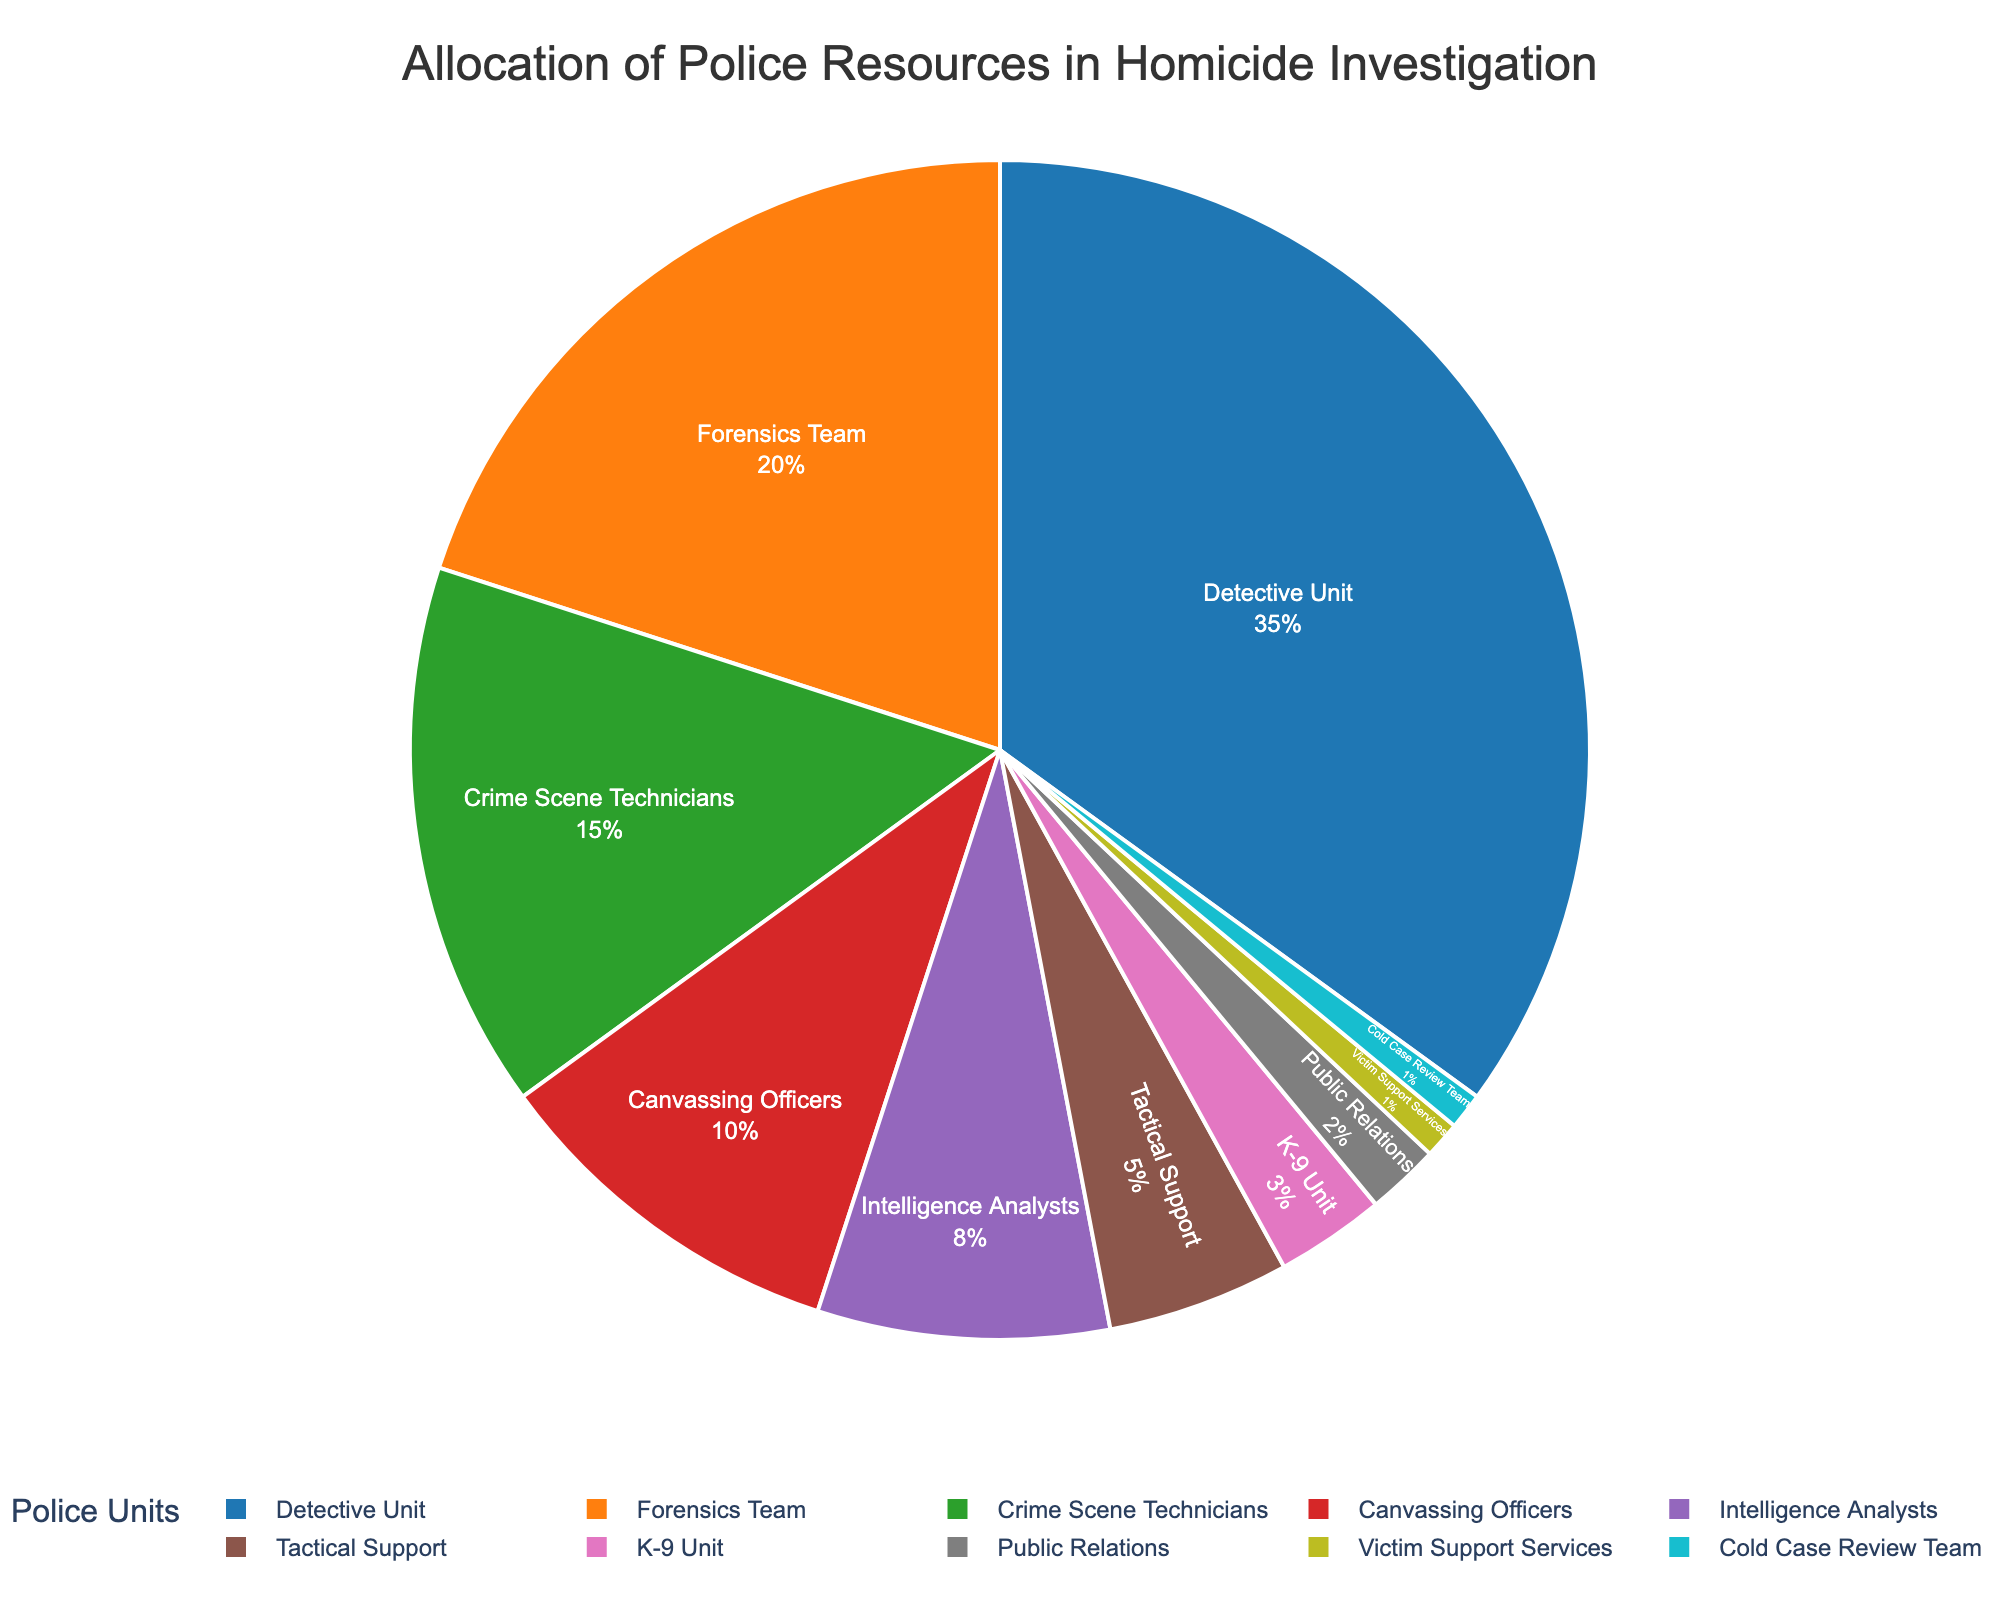Which unit has the highest allocation of police resources? The pie chart shows the percentage of resources allocated to each unit, and the largest segment represents the Detective Unit.
Answer: Detective Unit How much more percentage of resources does the Detective Unit receive compared to the Forensics Team? The Detective Unit receives 35%, and the Forensics Team receives 20%. The difference is 35% - 20%.
Answer: 15% What total percentage of resources is allocated to units involved in direct investigation activities (Detective Unit, Forensics Team, and Crime Scene Technicians)? Sum the percentages for Detective Unit (35%), Forensics Team (20%), and Crime Scene Technicians (15%): 35% + 20% + 15%.
Answer: 70% Which unit receives fewer resources, the Tactical Support or the Public Relations unit? The pie chart indicates Tactical Support receives 5%, and Public Relations receives 2%. 2% is less than 5%.
Answer: Public Relations Is the resource allocation for Intelligence Analysts greater than or equal to that of Crime Scene Technicians? The pie chart shows Intelligence Analysts with 8% and Crime Scene Technicians with 15%. 8% is less than 15%.
Answer: No What is the combined resource allocation for Canvassing Officers and the K-9 Unit? Add the percentages for Canvassing Officers (10%) and K-9 Unit (3%): 10% + 3%.
Answer: 13% How many units receive an equal resource allocation? The pie chart shows that the Victim Support Services and the Cold Case Review Team both receive 1% each.
Answer: 2 units Which unit uses the darkest color in the pie chart? The pie chart's color palette indicates the darkest segment color corresponds to the Detective Unit.
Answer: Detective Unit What is the total percentage of resources allocated to tactical and supporting roles (Tactical Support, K-9 Unit, and Public Relations)? Sum the percentages for Tactical Support (5%), K-9 Unit (3%), and Public Relations (2%): 5% + 3% + 2%.
Answer: 10% How do the allocations for Crime Scene Technicians and Intelligence Analysts compare? The pie chart reveals that Crime Scene Technicians have 15% while Intelligence Analysts have 8%. 15% is greater than 8%.
Answer: Crime Scene Technicians receive more 